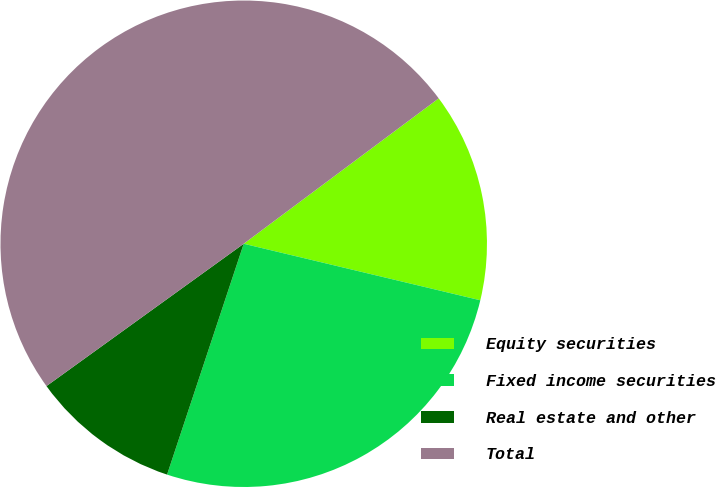Convert chart. <chart><loc_0><loc_0><loc_500><loc_500><pie_chart><fcel>Equity securities<fcel>Fixed income securities<fcel>Real estate and other<fcel>Total<nl><fcel>13.93%<fcel>26.37%<fcel>9.95%<fcel>49.75%<nl></chart> 